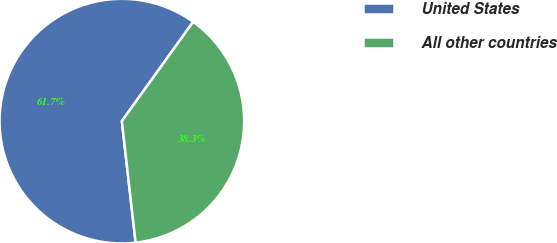Convert chart. <chart><loc_0><loc_0><loc_500><loc_500><pie_chart><fcel>United States<fcel>All other countries<nl><fcel>61.71%<fcel>38.29%<nl></chart> 